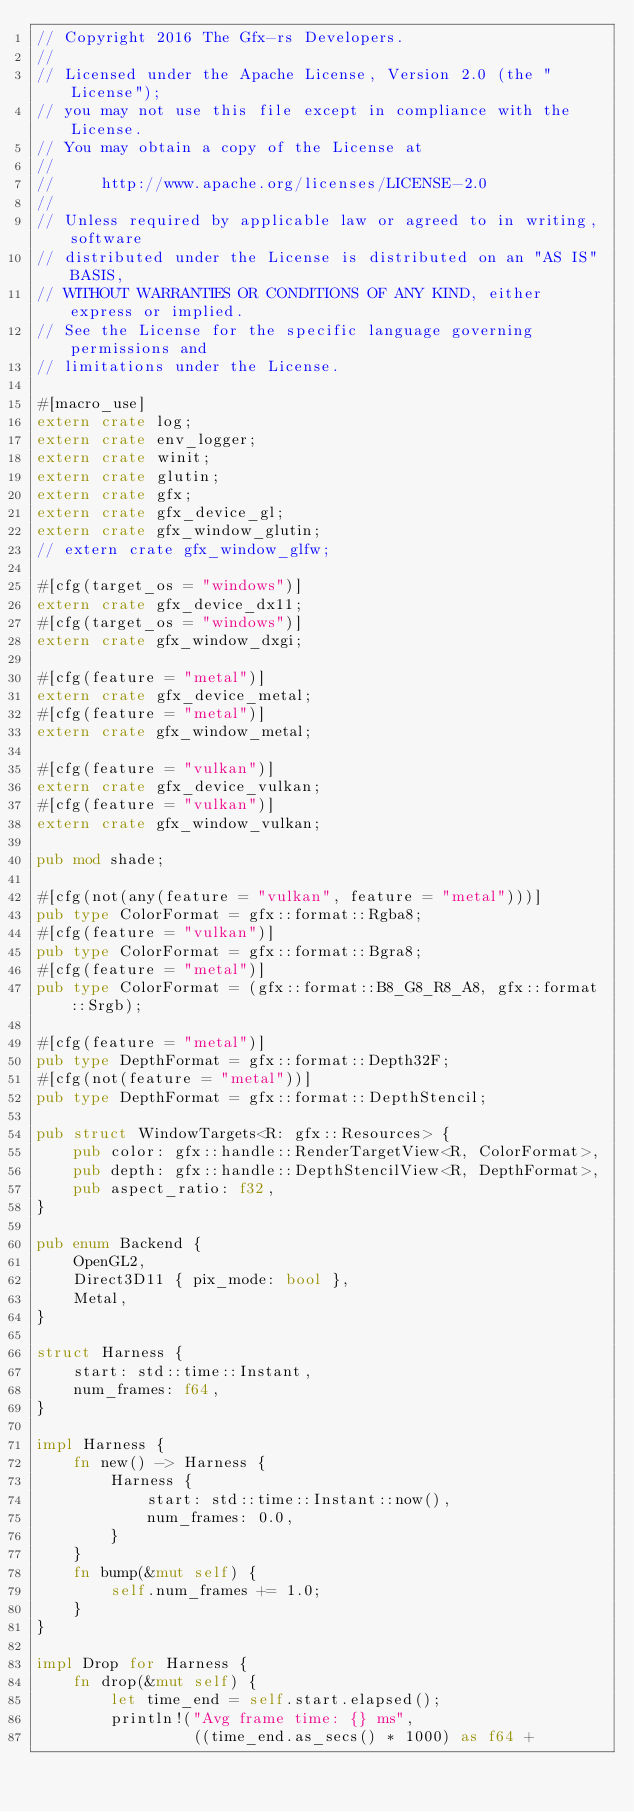Convert code to text. <code><loc_0><loc_0><loc_500><loc_500><_Rust_>// Copyright 2016 The Gfx-rs Developers.
//
// Licensed under the Apache License, Version 2.0 (the "License");
// you may not use this file except in compliance with the License.
// You may obtain a copy of the License at
//
//     http://www.apache.org/licenses/LICENSE-2.0
//
// Unless required by applicable law or agreed to in writing, software
// distributed under the License is distributed on an "AS IS" BASIS,
// WITHOUT WARRANTIES OR CONDITIONS OF ANY KIND, either express or implied.
// See the License for the specific language governing permissions and
// limitations under the License.

#[macro_use]
extern crate log;
extern crate env_logger;
extern crate winit;
extern crate glutin;
extern crate gfx;
extern crate gfx_device_gl;
extern crate gfx_window_glutin;
// extern crate gfx_window_glfw;

#[cfg(target_os = "windows")]
extern crate gfx_device_dx11;
#[cfg(target_os = "windows")]
extern crate gfx_window_dxgi;

#[cfg(feature = "metal")]
extern crate gfx_device_metal;
#[cfg(feature = "metal")]
extern crate gfx_window_metal;

#[cfg(feature = "vulkan")]
extern crate gfx_device_vulkan;
#[cfg(feature = "vulkan")]
extern crate gfx_window_vulkan;

pub mod shade;

#[cfg(not(any(feature = "vulkan", feature = "metal")))]
pub type ColorFormat = gfx::format::Rgba8;
#[cfg(feature = "vulkan")]
pub type ColorFormat = gfx::format::Bgra8;
#[cfg(feature = "metal")]
pub type ColorFormat = (gfx::format::B8_G8_R8_A8, gfx::format::Srgb);

#[cfg(feature = "metal")]
pub type DepthFormat = gfx::format::Depth32F;
#[cfg(not(feature = "metal"))]
pub type DepthFormat = gfx::format::DepthStencil;

pub struct WindowTargets<R: gfx::Resources> {
    pub color: gfx::handle::RenderTargetView<R, ColorFormat>,
    pub depth: gfx::handle::DepthStencilView<R, DepthFormat>,
    pub aspect_ratio: f32,
}

pub enum Backend {
    OpenGL2,
    Direct3D11 { pix_mode: bool },
    Metal,
}

struct Harness {
    start: std::time::Instant,
    num_frames: f64,
}

impl Harness {
    fn new() -> Harness {
        Harness {
            start: std::time::Instant::now(),
            num_frames: 0.0,
        }
    }
    fn bump(&mut self) {
        self.num_frames += 1.0;
    }
}

impl Drop for Harness {
    fn drop(&mut self) {
        let time_end = self.start.elapsed();
        println!("Avg frame time: {} ms",
                 ((time_end.as_secs() * 1000) as f64 +</code> 